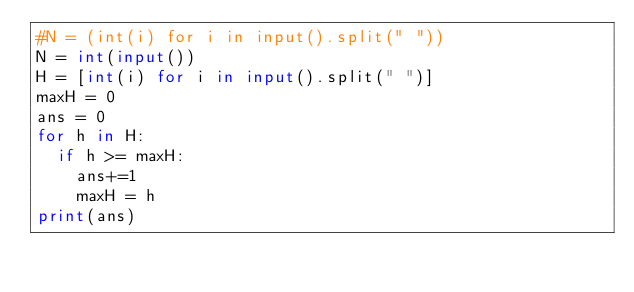<code> <loc_0><loc_0><loc_500><loc_500><_Python_>#N = (int(i) for i in input().split(" "))
N = int(input())
H = [int(i) for i in input().split(" ")]
maxH = 0
ans = 0
for h in H:
	if h >= maxH:
		ans+=1
		maxH = h
print(ans)</code> 